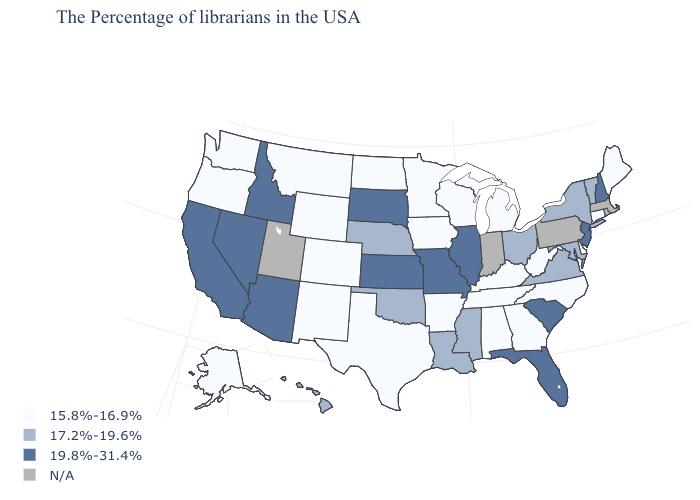What is the value of Rhode Island?
Write a very short answer. 17.2%-19.6%. What is the value of Nevada?
Answer briefly. 19.8%-31.4%. Does Hawaii have the lowest value in the West?
Keep it brief. No. Is the legend a continuous bar?
Answer briefly. No. What is the value of Michigan?
Short answer required. 15.8%-16.9%. Among the states that border Oregon , which have the highest value?
Answer briefly. Idaho, Nevada, California. What is the value of Wisconsin?
Keep it brief. 15.8%-16.9%. Does the map have missing data?
Concise answer only. Yes. Name the states that have a value in the range 19.8%-31.4%?
Concise answer only. New Hampshire, New Jersey, South Carolina, Florida, Illinois, Missouri, Kansas, South Dakota, Arizona, Idaho, Nevada, California. Name the states that have a value in the range N/A?
Quick response, please. Massachusetts, Pennsylvania, Indiana, Utah. Does the map have missing data?
Keep it brief. Yes. What is the value of Kentucky?
Be succinct. 15.8%-16.9%. Name the states that have a value in the range 19.8%-31.4%?
Short answer required. New Hampshire, New Jersey, South Carolina, Florida, Illinois, Missouri, Kansas, South Dakota, Arizona, Idaho, Nevada, California. What is the lowest value in states that border New Mexico?
Write a very short answer. 15.8%-16.9%. 